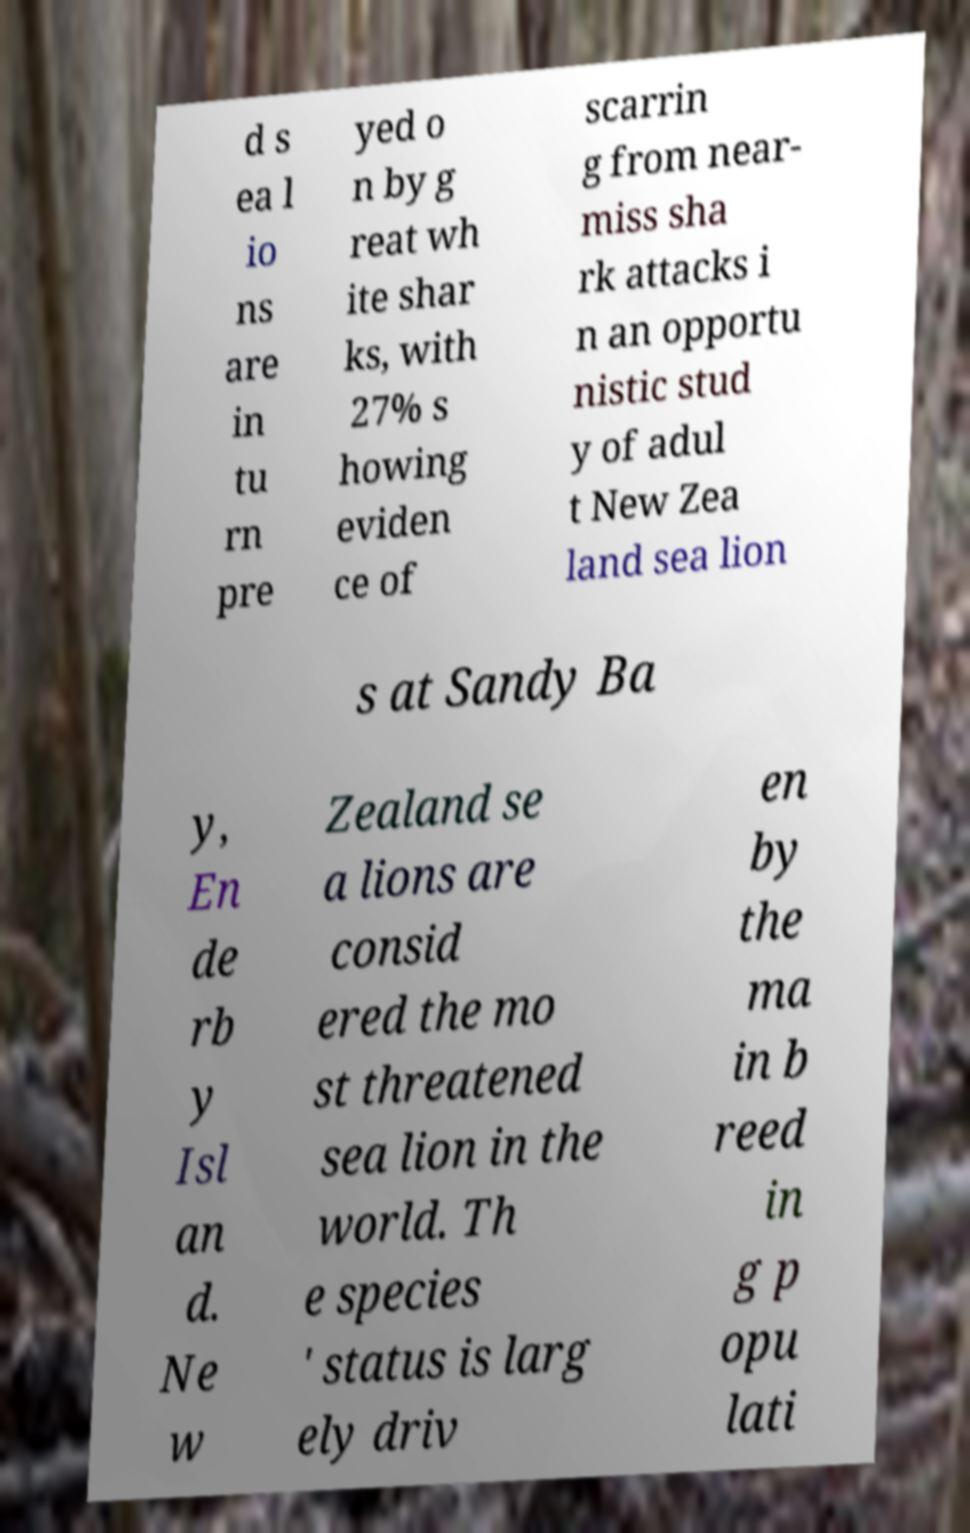Please identify and transcribe the text found in this image. d s ea l io ns are in tu rn pre yed o n by g reat wh ite shar ks, with 27% s howing eviden ce of scarrin g from near- miss sha rk attacks i n an opportu nistic stud y of adul t New Zea land sea lion s at Sandy Ba y, En de rb y Isl an d. Ne w Zealand se a lions are consid ered the mo st threatened sea lion in the world. Th e species ' status is larg ely driv en by the ma in b reed in g p opu lati 